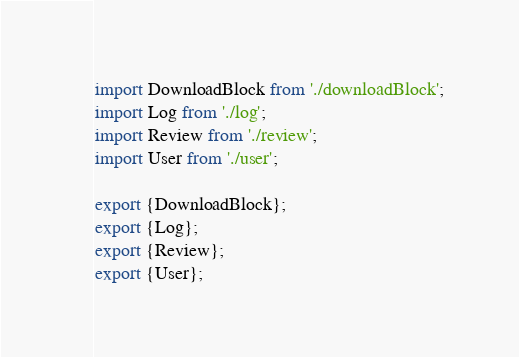Convert code to text. <code><loc_0><loc_0><loc_500><loc_500><_JavaScript_>import DownloadBlock from './downloadBlock';
import Log from './log';
import Review from './review';
import User from './user';

export {DownloadBlock};
export {Log};
export {Review};
export {User};
</code> 